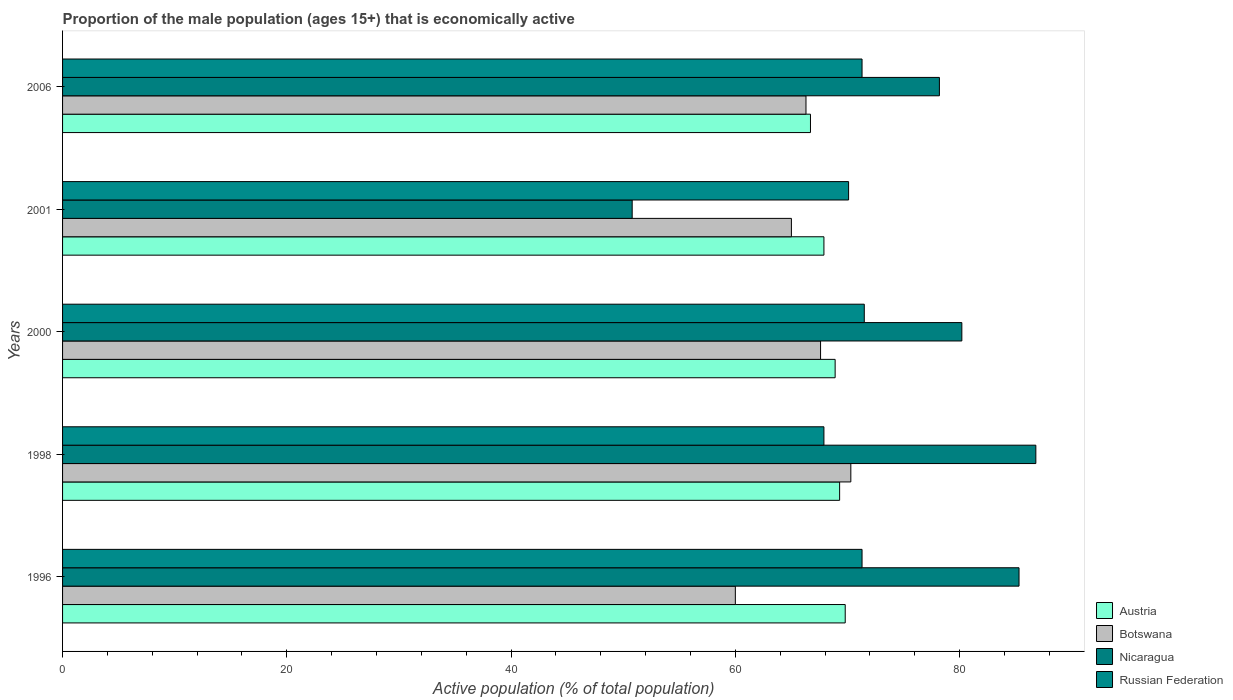How many different coloured bars are there?
Offer a terse response. 4. Are the number of bars per tick equal to the number of legend labels?
Provide a succinct answer. Yes. Are the number of bars on each tick of the Y-axis equal?
Provide a short and direct response. Yes. How many bars are there on the 5th tick from the top?
Your answer should be very brief. 4. How many bars are there on the 1st tick from the bottom?
Give a very brief answer. 4. What is the label of the 3rd group of bars from the top?
Make the answer very short. 2000. What is the proportion of the male population that is economically active in Austria in 2000?
Give a very brief answer. 68.9. Across all years, what is the maximum proportion of the male population that is economically active in Botswana?
Make the answer very short. 70.3. Across all years, what is the minimum proportion of the male population that is economically active in Botswana?
Your answer should be compact. 60. In which year was the proportion of the male population that is economically active in Nicaragua minimum?
Give a very brief answer. 2001. What is the total proportion of the male population that is economically active in Botswana in the graph?
Provide a succinct answer. 329.2. What is the difference between the proportion of the male population that is economically active in Nicaragua in 1998 and that in 2006?
Ensure brevity in your answer.  8.6. What is the difference between the proportion of the male population that is economically active in Botswana in 2000 and the proportion of the male population that is economically active in Austria in 1998?
Your answer should be very brief. -1.7. What is the average proportion of the male population that is economically active in Russian Federation per year?
Give a very brief answer. 70.42. In the year 2006, what is the difference between the proportion of the male population that is economically active in Botswana and proportion of the male population that is economically active in Austria?
Offer a very short reply. -0.4. In how many years, is the proportion of the male population that is economically active in Botswana greater than 36 %?
Offer a very short reply. 5. What is the ratio of the proportion of the male population that is economically active in Nicaragua in 1996 to that in 1998?
Your response must be concise. 0.98. What is the difference between the highest and the second highest proportion of the male population that is economically active in Austria?
Ensure brevity in your answer.  0.5. What is the difference between the highest and the lowest proportion of the male population that is economically active in Austria?
Offer a very short reply. 3.1. What does the 3rd bar from the bottom in 1998 represents?
Your response must be concise. Nicaragua. How many years are there in the graph?
Ensure brevity in your answer.  5. Does the graph contain any zero values?
Provide a succinct answer. No. Where does the legend appear in the graph?
Keep it short and to the point. Bottom right. How are the legend labels stacked?
Keep it short and to the point. Vertical. What is the title of the graph?
Your response must be concise. Proportion of the male population (ages 15+) that is economically active. What is the label or title of the X-axis?
Provide a succinct answer. Active population (% of total population). What is the Active population (% of total population) of Austria in 1996?
Provide a succinct answer. 69.8. What is the Active population (% of total population) in Botswana in 1996?
Provide a short and direct response. 60. What is the Active population (% of total population) of Nicaragua in 1996?
Ensure brevity in your answer.  85.3. What is the Active population (% of total population) in Russian Federation in 1996?
Offer a terse response. 71.3. What is the Active population (% of total population) in Austria in 1998?
Give a very brief answer. 69.3. What is the Active population (% of total population) in Botswana in 1998?
Give a very brief answer. 70.3. What is the Active population (% of total population) in Nicaragua in 1998?
Give a very brief answer. 86.8. What is the Active population (% of total population) of Russian Federation in 1998?
Offer a terse response. 67.9. What is the Active population (% of total population) of Austria in 2000?
Ensure brevity in your answer.  68.9. What is the Active population (% of total population) of Botswana in 2000?
Make the answer very short. 67.6. What is the Active population (% of total population) of Nicaragua in 2000?
Offer a terse response. 80.2. What is the Active population (% of total population) of Russian Federation in 2000?
Your response must be concise. 71.5. What is the Active population (% of total population) of Austria in 2001?
Make the answer very short. 67.9. What is the Active population (% of total population) in Botswana in 2001?
Your answer should be compact. 65. What is the Active population (% of total population) in Nicaragua in 2001?
Offer a very short reply. 50.8. What is the Active population (% of total population) in Russian Federation in 2001?
Offer a very short reply. 70.1. What is the Active population (% of total population) in Austria in 2006?
Your answer should be compact. 66.7. What is the Active population (% of total population) of Botswana in 2006?
Your response must be concise. 66.3. What is the Active population (% of total population) of Nicaragua in 2006?
Make the answer very short. 78.2. What is the Active population (% of total population) of Russian Federation in 2006?
Offer a terse response. 71.3. Across all years, what is the maximum Active population (% of total population) of Austria?
Give a very brief answer. 69.8. Across all years, what is the maximum Active population (% of total population) of Botswana?
Provide a short and direct response. 70.3. Across all years, what is the maximum Active population (% of total population) of Nicaragua?
Give a very brief answer. 86.8. Across all years, what is the maximum Active population (% of total population) of Russian Federation?
Keep it short and to the point. 71.5. Across all years, what is the minimum Active population (% of total population) of Austria?
Make the answer very short. 66.7. Across all years, what is the minimum Active population (% of total population) in Nicaragua?
Keep it short and to the point. 50.8. Across all years, what is the minimum Active population (% of total population) in Russian Federation?
Keep it short and to the point. 67.9. What is the total Active population (% of total population) of Austria in the graph?
Provide a short and direct response. 342.6. What is the total Active population (% of total population) in Botswana in the graph?
Give a very brief answer. 329.2. What is the total Active population (% of total population) in Nicaragua in the graph?
Make the answer very short. 381.3. What is the total Active population (% of total population) in Russian Federation in the graph?
Your answer should be compact. 352.1. What is the difference between the Active population (% of total population) in Russian Federation in 1996 and that in 1998?
Provide a succinct answer. 3.4. What is the difference between the Active population (% of total population) in Botswana in 1996 and that in 2000?
Offer a terse response. -7.6. What is the difference between the Active population (% of total population) in Nicaragua in 1996 and that in 2000?
Your answer should be very brief. 5.1. What is the difference between the Active population (% of total population) of Austria in 1996 and that in 2001?
Provide a succinct answer. 1.9. What is the difference between the Active population (% of total population) in Botswana in 1996 and that in 2001?
Provide a short and direct response. -5. What is the difference between the Active population (% of total population) of Nicaragua in 1996 and that in 2001?
Keep it short and to the point. 34.5. What is the difference between the Active population (% of total population) of Austria in 1996 and that in 2006?
Keep it short and to the point. 3.1. What is the difference between the Active population (% of total population) of Botswana in 1998 and that in 2000?
Offer a very short reply. 2.7. What is the difference between the Active population (% of total population) of Botswana in 1998 and that in 2001?
Provide a short and direct response. 5.3. What is the difference between the Active population (% of total population) in Austria in 1998 and that in 2006?
Your response must be concise. 2.6. What is the difference between the Active population (% of total population) in Nicaragua in 1998 and that in 2006?
Offer a terse response. 8.6. What is the difference between the Active population (% of total population) in Russian Federation in 1998 and that in 2006?
Your answer should be very brief. -3.4. What is the difference between the Active population (% of total population) of Austria in 2000 and that in 2001?
Make the answer very short. 1. What is the difference between the Active population (% of total population) of Botswana in 2000 and that in 2001?
Make the answer very short. 2.6. What is the difference between the Active population (% of total population) of Nicaragua in 2000 and that in 2001?
Keep it short and to the point. 29.4. What is the difference between the Active population (% of total population) of Austria in 2000 and that in 2006?
Provide a short and direct response. 2.2. What is the difference between the Active population (% of total population) in Botswana in 2000 and that in 2006?
Make the answer very short. 1.3. What is the difference between the Active population (% of total population) of Nicaragua in 2000 and that in 2006?
Your answer should be very brief. 2. What is the difference between the Active population (% of total population) of Russian Federation in 2000 and that in 2006?
Provide a succinct answer. 0.2. What is the difference between the Active population (% of total population) in Austria in 2001 and that in 2006?
Your response must be concise. 1.2. What is the difference between the Active population (% of total population) of Nicaragua in 2001 and that in 2006?
Provide a short and direct response. -27.4. What is the difference between the Active population (% of total population) in Austria in 1996 and the Active population (% of total population) in Botswana in 1998?
Provide a short and direct response. -0.5. What is the difference between the Active population (% of total population) in Austria in 1996 and the Active population (% of total population) in Russian Federation in 1998?
Offer a terse response. 1.9. What is the difference between the Active population (% of total population) of Botswana in 1996 and the Active population (% of total population) of Nicaragua in 1998?
Provide a short and direct response. -26.8. What is the difference between the Active population (% of total population) in Nicaragua in 1996 and the Active population (% of total population) in Russian Federation in 1998?
Make the answer very short. 17.4. What is the difference between the Active population (% of total population) in Botswana in 1996 and the Active population (% of total population) in Nicaragua in 2000?
Ensure brevity in your answer.  -20.2. What is the difference between the Active population (% of total population) of Austria in 1996 and the Active population (% of total population) of Botswana in 2001?
Keep it short and to the point. 4.8. What is the difference between the Active population (% of total population) of Botswana in 1996 and the Active population (% of total population) of Nicaragua in 2001?
Make the answer very short. 9.2. What is the difference between the Active population (% of total population) of Austria in 1996 and the Active population (% of total population) of Botswana in 2006?
Your answer should be very brief. 3.5. What is the difference between the Active population (% of total population) of Austria in 1996 and the Active population (% of total population) of Nicaragua in 2006?
Offer a very short reply. -8.4. What is the difference between the Active population (% of total population) of Botswana in 1996 and the Active population (% of total population) of Nicaragua in 2006?
Keep it short and to the point. -18.2. What is the difference between the Active population (% of total population) of Botswana in 1996 and the Active population (% of total population) of Russian Federation in 2006?
Your answer should be compact. -11.3. What is the difference between the Active population (% of total population) of Nicaragua in 1996 and the Active population (% of total population) of Russian Federation in 2006?
Your answer should be compact. 14. What is the difference between the Active population (% of total population) of Austria in 1998 and the Active population (% of total population) of Botswana in 2000?
Make the answer very short. 1.7. What is the difference between the Active population (% of total population) of Botswana in 1998 and the Active population (% of total population) of Nicaragua in 2000?
Your answer should be compact. -9.9. What is the difference between the Active population (% of total population) in Nicaragua in 1998 and the Active population (% of total population) in Russian Federation in 2000?
Provide a short and direct response. 15.3. What is the difference between the Active population (% of total population) of Austria in 1998 and the Active population (% of total population) of Botswana in 2001?
Ensure brevity in your answer.  4.3. What is the difference between the Active population (% of total population) of Austria in 1998 and the Active population (% of total population) of Russian Federation in 2001?
Your answer should be compact. -0.8. What is the difference between the Active population (% of total population) in Botswana in 1998 and the Active population (% of total population) in Nicaragua in 2001?
Ensure brevity in your answer.  19.5. What is the difference between the Active population (% of total population) in Botswana in 1998 and the Active population (% of total population) in Russian Federation in 2001?
Your answer should be compact. 0.2. What is the difference between the Active population (% of total population) in Austria in 1998 and the Active population (% of total population) in Nicaragua in 2006?
Make the answer very short. -8.9. What is the difference between the Active population (% of total population) of Nicaragua in 1998 and the Active population (% of total population) of Russian Federation in 2006?
Offer a terse response. 15.5. What is the difference between the Active population (% of total population) of Austria in 2000 and the Active population (% of total population) of Nicaragua in 2001?
Your answer should be very brief. 18.1. What is the difference between the Active population (% of total population) in Austria in 2000 and the Active population (% of total population) in Russian Federation in 2001?
Your answer should be compact. -1.2. What is the difference between the Active population (% of total population) in Botswana in 2000 and the Active population (% of total population) in Russian Federation in 2001?
Your answer should be compact. -2.5. What is the difference between the Active population (% of total population) of Botswana in 2000 and the Active population (% of total population) of Russian Federation in 2006?
Your answer should be compact. -3.7. What is the difference between the Active population (% of total population) of Nicaragua in 2000 and the Active population (% of total population) of Russian Federation in 2006?
Provide a succinct answer. 8.9. What is the difference between the Active population (% of total population) of Austria in 2001 and the Active population (% of total population) of Botswana in 2006?
Ensure brevity in your answer.  1.6. What is the difference between the Active population (% of total population) in Austria in 2001 and the Active population (% of total population) in Nicaragua in 2006?
Ensure brevity in your answer.  -10.3. What is the difference between the Active population (% of total population) in Austria in 2001 and the Active population (% of total population) in Russian Federation in 2006?
Keep it short and to the point. -3.4. What is the difference between the Active population (% of total population) of Botswana in 2001 and the Active population (% of total population) of Nicaragua in 2006?
Keep it short and to the point. -13.2. What is the difference between the Active population (% of total population) of Botswana in 2001 and the Active population (% of total population) of Russian Federation in 2006?
Give a very brief answer. -6.3. What is the difference between the Active population (% of total population) in Nicaragua in 2001 and the Active population (% of total population) in Russian Federation in 2006?
Your answer should be compact. -20.5. What is the average Active population (% of total population) in Austria per year?
Your response must be concise. 68.52. What is the average Active population (% of total population) of Botswana per year?
Ensure brevity in your answer.  65.84. What is the average Active population (% of total population) of Nicaragua per year?
Provide a succinct answer. 76.26. What is the average Active population (% of total population) of Russian Federation per year?
Your response must be concise. 70.42. In the year 1996, what is the difference between the Active population (% of total population) of Austria and Active population (% of total population) of Nicaragua?
Your answer should be very brief. -15.5. In the year 1996, what is the difference between the Active population (% of total population) of Botswana and Active population (% of total population) of Nicaragua?
Offer a very short reply. -25.3. In the year 1996, what is the difference between the Active population (% of total population) of Nicaragua and Active population (% of total population) of Russian Federation?
Give a very brief answer. 14. In the year 1998, what is the difference between the Active population (% of total population) of Austria and Active population (% of total population) of Nicaragua?
Provide a short and direct response. -17.5. In the year 1998, what is the difference between the Active population (% of total population) of Botswana and Active population (% of total population) of Nicaragua?
Provide a succinct answer. -16.5. In the year 1998, what is the difference between the Active population (% of total population) of Nicaragua and Active population (% of total population) of Russian Federation?
Keep it short and to the point. 18.9. In the year 2000, what is the difference between the Active population (% of total population) in Austria and Active population (% of total population) in Botswana?
Provide a short and direct response. 1.3. In the year 2000, what is the difference between the Active population (% of total population) in Austria and Active population (% of total population) in Nicaragua?
Make the answer very short. -11.3. In the year 2000, what is the difference between the Active population (% of total population) in Botswana and Active population (% of total population) in Nicaragua?
Offer a terse response. -12.6. In the year 2000, what is the difference between the Active population (% of total population) in Nicaragua and Active population (% of total population) in Russian Federation?
Make the answer very short. 8.7. In the year 2001, what is the difference between the Active population (% of total population) in Austria and Active population (% of total population) in Nicaragua?
Make the answer very short. 17.1. In the year 2001, what is the difference between the Active population (% of total population) of Botswana and Active population (% of total population) of Nicaragua?
Your answer should be compact. 14.2. In the year 2001, what is the difference between the Active population (% of total population) in Nicaragua and Active population (% of total population) in Russian Federation?
Your answer should be very brief. -19.3. In the year 2006, what is the difference between the Active population (% of total population) in Austria and Active population (% of total population) in Botswana?
Your answer should be compact. 0.4. In the year 2006, what is the difference between the Active population (% of total population) of Nicaragua and Active population (% of total population) of Russian Federation?
Offer a very short reply. 6.9. What is the ratio of the Active population (% of total population) in Botswana in 1996 to that in 1998?
Your response must be concise. 0.85. What is the ratio of the Active population (% of total population) of Nicaragua in 1996 to that in 1998?
Provide a short and direct response. 0.98. What is the ratio of the Active population (% of total population) in Russian Federation in 1996 to that in 1998?
Your answer should be very brief. 1.05. What is the ratio of the Active population (% of total population) in Austria in 1996 to that in 2000?
Ensure brevity in your answer.  1.01. What is the ratio of the Active population (% of total population) of Botswana in 1996 to that in 2000?
Offer a very short reply. 0.89. What is the ratio of the Active population (% of total population) of Nicaragua in 1996 to that in 2000?
Provide a succinct answer. 1.06. What is the ratio of the Active population (% of total population) in Austria in 1996 to that in 2001?
Provide a succinct answer. 1.03. What is the ratio of the Active population (% of total population) in Botswana in 1996 to that in 2001?
Provide a succinct answer. 0.92. What is the ratio of the Active population (% of total population) in Nicaragua in 1996 to that in 2001?
Your response must be concise. 1.68. What is the ratio of the Active population (% of total population) in Russian Federation in 1996 to that in 2001?
Provide a succinct answer. 1.02. What is the ratio of the Active population (% of total population) in Austria in 1996 to that in 2006?
Offer a very short reply. 1.05. What is the ratio of the Active population (% of total population) in Botswana in 1996 to that in 2006?
Ensure brevity in your answer.  0.91. What is the ratio of the Active population (% of total population) of Nicaragua in 1996 to that in 2006?
Offer a terse response. 1.09. What is the ratio of the Active population (% of total population) of Russian Federation in 1996 to that in 2006?
Ensure brevity in your answer.  1. What is the ratio of the Active population (% of total population) in Austria in 1998 to that in 2000?
Make the answer very short. 1.01. What is the ratio of the Active population (% of total population) in Botswana in 1998 to that in 2000?
Offer a terse response. 1.04. What is the ratio of the Active population (% of total population) of Nicaragua in 1998 to that in 2000?
Offer a terse response. 1.08. What is the ratio of the Active population (% of total population) of Russian Federation in 1998 to that in 2000?
Your answer should be compact. 0.95. What is the ratio of the Active population (% of total population) in Austria in 1998 to that in 2001?
Offer a terse response. 1.02. What is the ratio of the Active population (% of total population) in Botswana in 1998 to that in 2001?
Your response must be concise. 1.08. What is the ratio of the Active population (% of total population) of Nicaragua in 1998 to that in 2001?
Your answer should be compact. 1.71. What is the ratio of the Active population (% of total population) of Russian Federation in 1998 to that in 2001?
Ensure brevity in your answer.  0.97. What is the ratio of the Active population (% of total population) in Austria in 1998 to that in 2006?
Provide a succinct answer. 1.04. What is the ratio of the Active population (% of total population) in Botswana in 1998 to that in 2006?
Keep it short and to the point. 1.06. What is the ratio of the Active population (% of total population) of Nicaragua in 1998 to that in 2006?
Your answer should be compact. 1.11. What is the ratio of the Active population (% of total population) in Russian Federation in 1998 to that in 2006?
Make the answer very short. 0.95. What is the ratio of the Active population (% of total population) of Austria in 2000 to that in 2001?
Your response must be concise. 1.01. What is the ratio of the Active population (% of total population) in Nicaragua in 2000 to that in 2001?
Provide a short and direct response. 1.58. What is the ratio of the Active population (% of total population) in Austria in 2000 to that in 2006?
Your answer should be compact. 1.03. What is the ratio of the Active population (% of total population) in Botswana in 2000 to that in 2006?
Provide a short and direct response. 1.02. What is the ratio of the Active population (% of total population) of Nicaragua in 2000 to that in 2006?
Keep it short and to the point. 1.03. What is the ratio of the Active population (% of total population) in Austria in 2001 to that in 2006?
Provide a succinct answer. 1.02. What is the ratio of the Active population (% of total population) in Botswana in 2001 to that in 2006?
Give a very brief answer. 0.98. What is the ratio of the Active population (% of total population) in Nicaragua in 2001 to that in 2006?
Offer a terse response. 0.65. What is the ratio of the Active population (% of total population) in Russian Federation in 2001 to that in 2006?
Make the answer very short. 0.98. What is the difference between the highest and the lowest Active population (% of total population) of Nicaragua?
Provide a short and direct response. 36. What is the difference between the highest and the lowest Active population (% of total population) of Russian Federation?
Your answer should be compact. 3.6. 